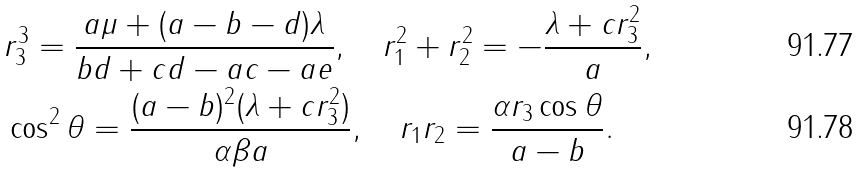Convert formula to latex. <formula><loc_0><loc_0><loc_500><loc_500>& r _ { 3 } ^ { 3 } = \frac { a \mu + ( a - b - d ) \lambda } { b d + c d - a c - a e } , \quad r _ { 1 } ^ { 2 } + r _ { 2 } ^ { 2 } = - \frac { \lambda + c r _ { 3 } ^ { 2 } } { a } , \\ & \cos ^ { 2 } \theta = \frac { ( a - b ) ^ { 2 } ( \lambda + c r _ { 3 } ^ { 2 } ) } { \alpha \beta a } , \quad r _ { 1 } r _ { 2 } = \frac { \alpha r _ { 3 } \cos \theta } { a - b } .</formula> 